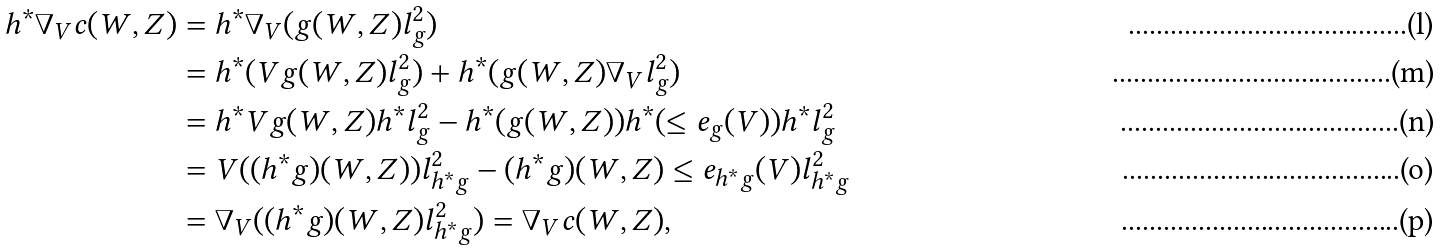<formula> <loc_0><loc_0><loc_500><loc_500>h ^ { * } \nabla _ { V } c ( W , Z ) & = h ^ { * } \nabla _ { V } ( g ( W , Z ) l ^ { 2 } _ { g } ) \\ & = h ^ { * } ( V g ( W , Z ) l ^ { 2 } _ { g } ) + h ^ { * } ( g ( W , Z ) \nabla _ { V } l ^ { 2 } _ { g } ) \\ & = h ^ { * } V g ( W , Z ) h ^ { * } l ^ { 2 } _ { g } - h ^ { * } ( g ( W , Z ) ) h ^ { * } ( \leq e _ { g } ( V ) ) h ^ { * } l ^ { 2 } _ { g } \\ & = V ( ( h ^ { * } g ) ( W , Z ) ) l ^ { 2 } _ { h ^ { * } g } - ( h ^ { * } g ) ( W , Z ) \leq e _ { h ^ { * } g } ( V ) l ^ { 2 } _ { h ^ { * } g } \\ & = \nabla _ { V } ( ( h ^ { * } g ) ( W , Z ) l ^ { 2 } _ { h ^ { * } g } ) = \nabla _ { V } c ( W , Z ) ,</formula> 